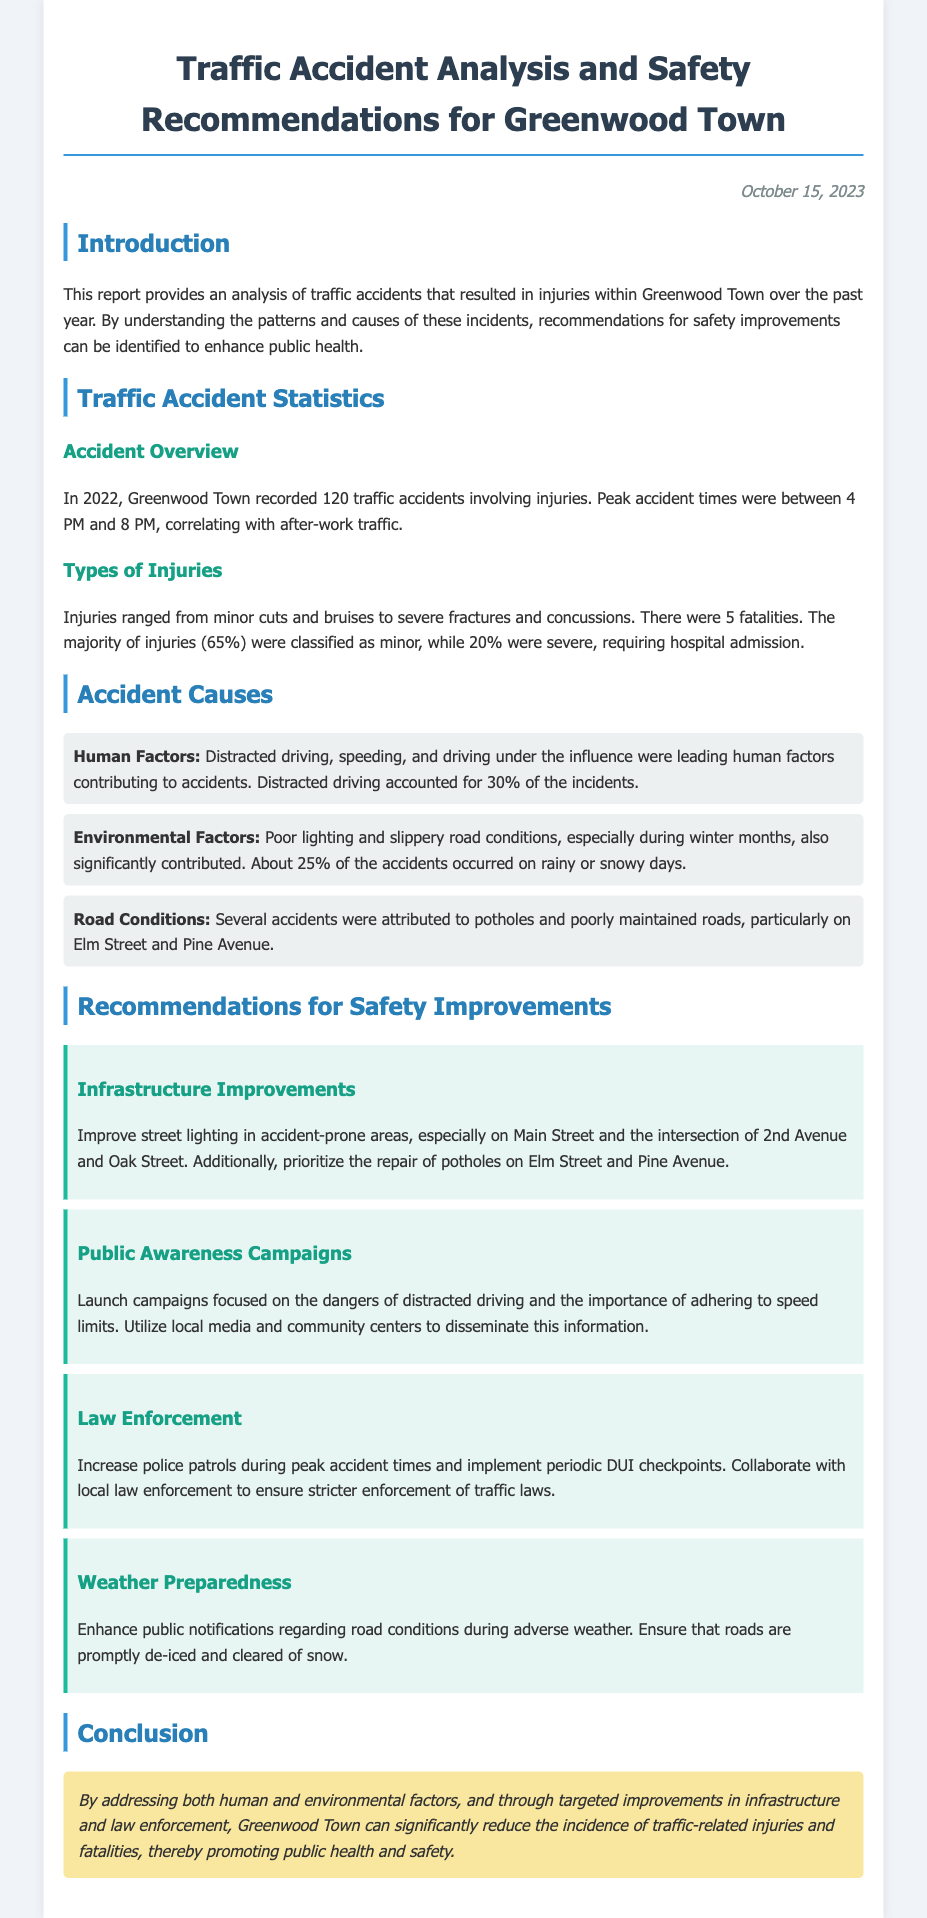What was the total number of traffic accidents in 2022? The total number of traffic accidents in 2022 is mentioned in the document as 120.
Answer: 120 What percentage of injuries were classified as minor? The document states that 65% of the injuries were classified as minor.
Answer: 65% What time period saw peak traffic accidents? The document indicates that peak accident times were between 4 PM and 8 PM.
Answer: 4 PM and 8 PM What environmental factor contributed to 25% of the accidents? The document attributes 25% of the accidents to poor weather conditions, specifically rainy or snowy days.
Answer: Rainy or snowy days Which street is mentioned for pothole issues? The document highlights potholes as a significant issue specifically on Elm Street and Pine Avenue.
Answer: Elm Street and Pine Avenue What is one of the recommendations for law enforcement? The document suggests increasing police patrols during peak accident times as a recommendation for law enforcement.
Answer: Increase police patrols How many fatalities were reported? The document states that there were 5 fatalities reported in the traffic accidents.
Answer: 5 What type of campaign is recommended to address distracted driving? The document recommends launching public awareness campaigns focused on the dangers of distracted driving.
Answer: Public awareness campaigns 